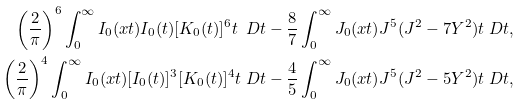<formula> <loc_0><loc_0><loc_500><loc_500>\left ( \frac { 2 } { \pi } \right ) ^ { 6 } \int _ { 0 } ^ { \infty } I _ { 0 } ( x t ) I _ { 0 } ( t ) [ K _ { 0 } ( t ) ] ^ { 6 } t \ D t & - \frac { 8 } { 7 } \int _ { 0 } ^ { \infty } J _ { 0 } ( x t ) J ^ { 5 } ( J ^ { 2 } - 7 Y ^ { 2 } ) t \ D t , \\ \left ( \frac { 2 } { \pi } \right ) ^ { 4 } \int _ { 0 } ^ { \infty } I _ { 0 } ( x t ) [ I _ { 0 } ( t ) ] ^ { 3 } [ K _ { 0 } ( t ) ] ^ { 4 } t \ D t & - \frac { 4 } { 5 } \int _ { 0 } ^ { \infty } J _ { 0 } ( x t ) J ^ { 5 } ( J ^ { 2 } - 5 Y ^ { 2 } ) t \ D t ,</formula> 